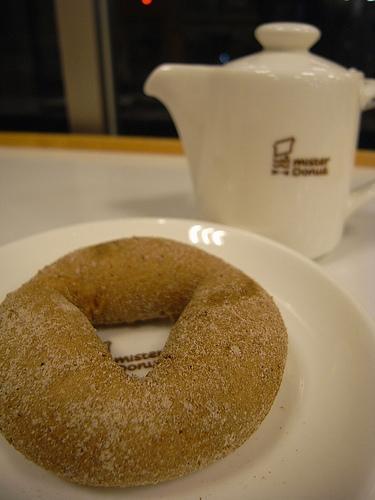How many sinks are sitting in this bathroom?
Give a very brief answer. 0. 